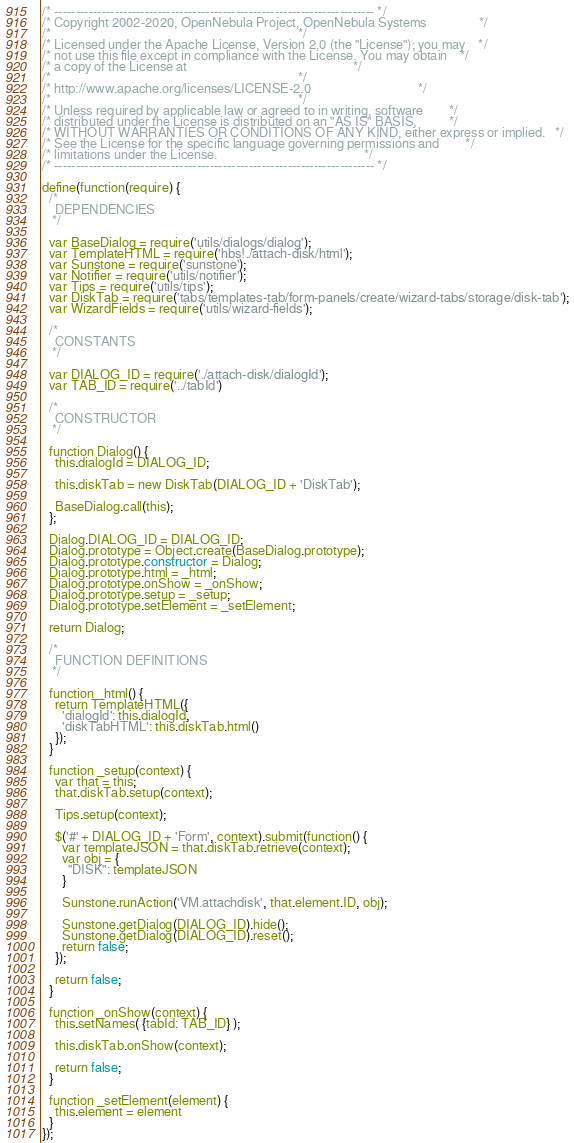<code> <loc_0><loc_0><loc_500><loc_500><_JavaScript_>/* -------------------------------------------------------------------------- */
/* Copyright 2002-2020, OpenNebula Project, OpenNebula Systems                */
/*                                                                            */
/* Licensed under the Apache License, Version 2.0 (the "License"); you may    */
/* not use this file except in compliance with the License. You may obtain    */
/* a copy of the License at                                                   */
/*                                                                            */
/* http://www.apache.org/licenses/LICENSE-2.0                                 */
/*                                                                            */
/* Unless required by applicable law or agreed to in writing, software        */
/* distributed under the License is distributed on an "AS IS" BASIS,          */
/* WITHOUT WARRANTIES OR CONDITIONS OF ANY KIND, either express or implied.   */
/* See the License for the specific language governing permissions and        */
/* limitations under the License.                                             */
/* -------------------------------------------------------------------------- */

define(function(require) {
  /*
    DEPENDENCIES
   */

  var BaseDialog = require('utils/dialogs/dialog');
  var TemplateHTML = require('hbs!./attach-disk/html');
  var Sunstone = require('sunstone');
  var Notifier = require('utils/notifier');
  var Tips = require('utils/tips');
  var DiskTab = require('tabs/templates-tab/form-panels/create/wizard-tabs/storage/disk-tab');
  var WizardFields = require('utils/wizard-fields');

  /*
    CONSTANTS
   */

  var DIALOG_ID = require('./attach-disk/dialogId');
  var TAB_ID = require('../tabId')

  /*
    CONSTRUCTOR
   */

  function Dialog() {
    this.dialogId = DIALOG_ID;

    this.diskTab = new DiskTab(DIALOG_ID + 'DiskTab');

    BaseDialog.call(this);
  };

  Dialog.DIALOG_ID = DIALOG_ID;
  Dialog.prototype = Object.create(BaseDialog.prototype);
  Dialog.prototype.constructor = Dialog;
  Dialog.prototype.html = _html;
  Dialog.prototype.onShow = _onShow;
  Dialog.prototype.setup = _setup;
  Dialog.prototype.setElement = _setElement;

  return Dialog;

  /*
    FUNCTION DEFINITIONS
   */

  function _html() {
    return TemplateHTML({
      'dialogId': this.dialogId,
      'diskTabHTML': this.diskTab.html()
    });
  }

  function _setup(context) {
    var that = this;
    that.diskTab.setup(context);

    Tips.setup(context);

    $('#' + DIALOG_ID + 'Form', context).submit(function() {
      var templateJSON = that.diskTab.retrieve(context);
      var obj = {
        "DISK": templateJSON
      }

      Sunstone.runAction('VM.attachdisk', that.element.ID, obj);

      Sunstone.getDialog(DIALOG_ID).hide();
      Sunstone.getDialog(DIALOG_ID).reset();
      return false;
    });

    return false;
  }

  function _onShow(context) {
    this.setNames( {tabId: TAB_ID} );

    this.diskTab.onShow(context);

    return false;
  }

  function _setElement(element) {
    this.element = element
  }
});
</code> 